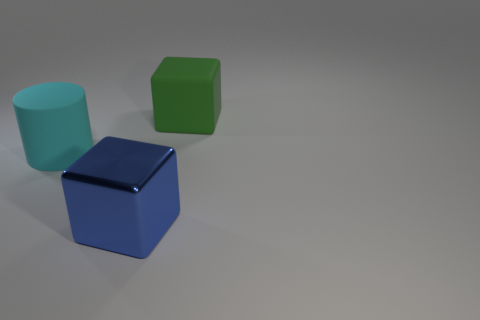Is the number of gray cylinders less than the number of cyan rubber cylinders?
Your answer should be compact. Yes. What is the shape of the large cyan object that is the same material as the green object?
Provide a succinct answer. Cylinder. There is a matte block; are there any big green rubber cubes to the right of it?
Give a very brief answer. No. Are there fewer blue metallic things that are on the left side of the large cyan cylinder than big yellow metal blocks?
Offer a very short reply. No. What is the big cyan thing made of?
Your answer should be compact. Rubber. The large rubber cylinder is what color?
Make the answer very short. Cyan. There is a thing that is in front of the green cube and right of the rubber cylinder; what is its color?
Your answer should be compact. Blue. Is there anything else that is the same material as the large cyan object?
Ensure brevity in your answer.  Yes. Is the cyan object made of the same material as the thing in front of the large rubber cylinder?
Your answer should be very brief. No. There is a matte object to the left of the large matte object that is behind the big matte cylinder; what size is it?
Keep it short and to the point. Large. 